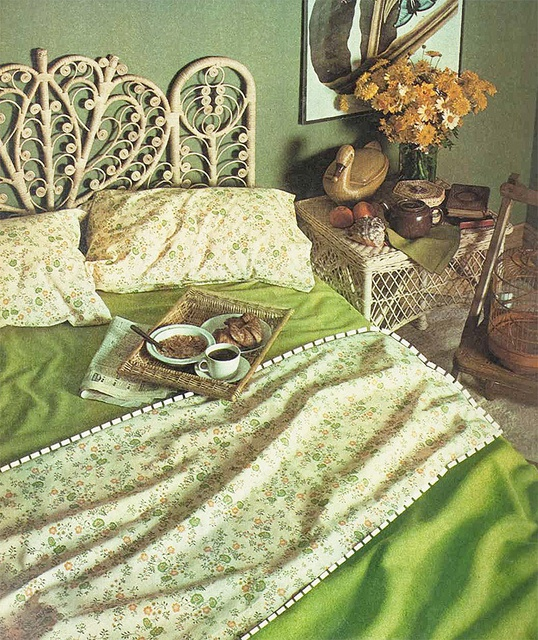Describe the objects in this image and their specific colors. I can see bed in gray, olive, beige, and darkgreen tones, chair in gray, maroon, and black tones, bowl in gray and beige tones, cup in gray, beige, black, and olive tones, and spoon in gray, black, and darkgreen tones in this image. 